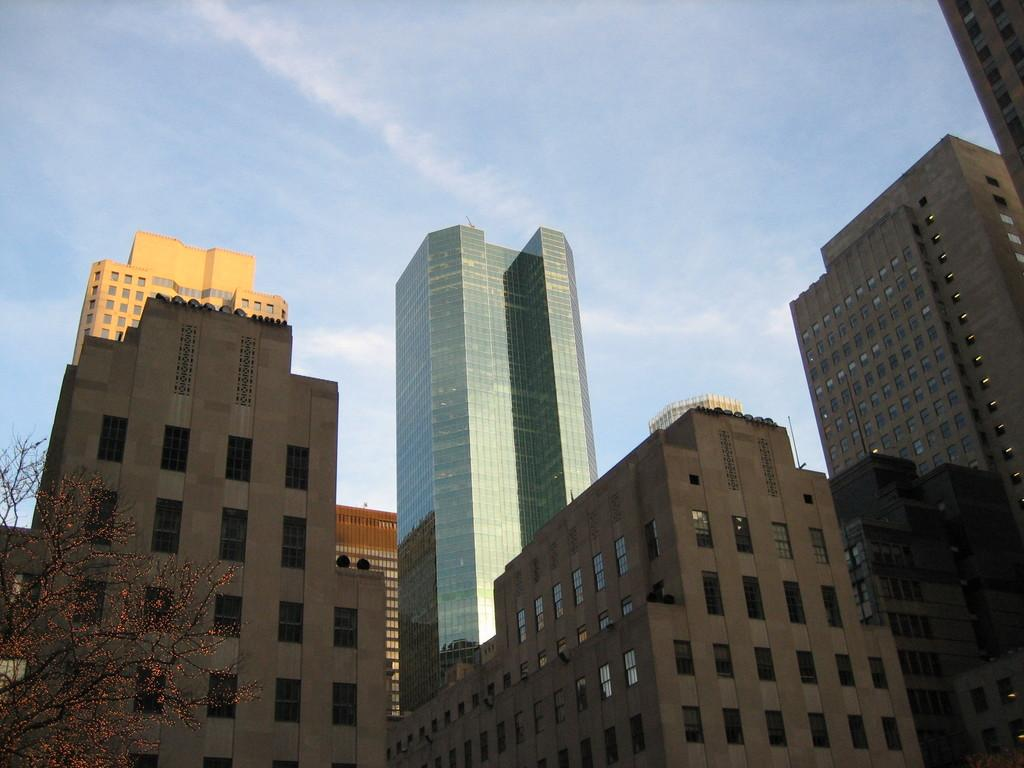What can be seen in the foreground of the image? There are buildings and a tree in the foreground of the image. What is visible in the background of the image? The sky is visible in the image. Can you determine the time of day when the image was taken? Yes, the image was taken during the day. How many cakes are being served to the family by the parent in the image? There is no family, parent, or cakes present in the image. 